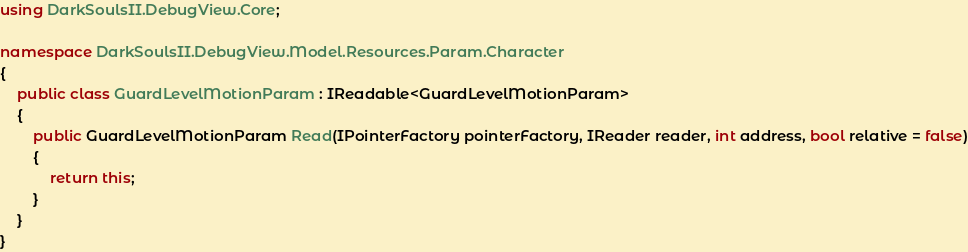Convert code to text. <code><loc_0><loc_0><loc_500><loc_500><_C#_>using DarkSoulsII.DebugView.Core;

namespace DarkSoulsII.DebugView.Model.Resources.Param.Character
{
    public class GuardLevelMotionParam : IReadable<GuardLevelMotionParam>
    {
        public GuardLevelMotionParam Read(IPointerFactory pointerFactory, IReader reader, int address, bool relative = false)
        {
            return this;
        }
    }
}
</code> 